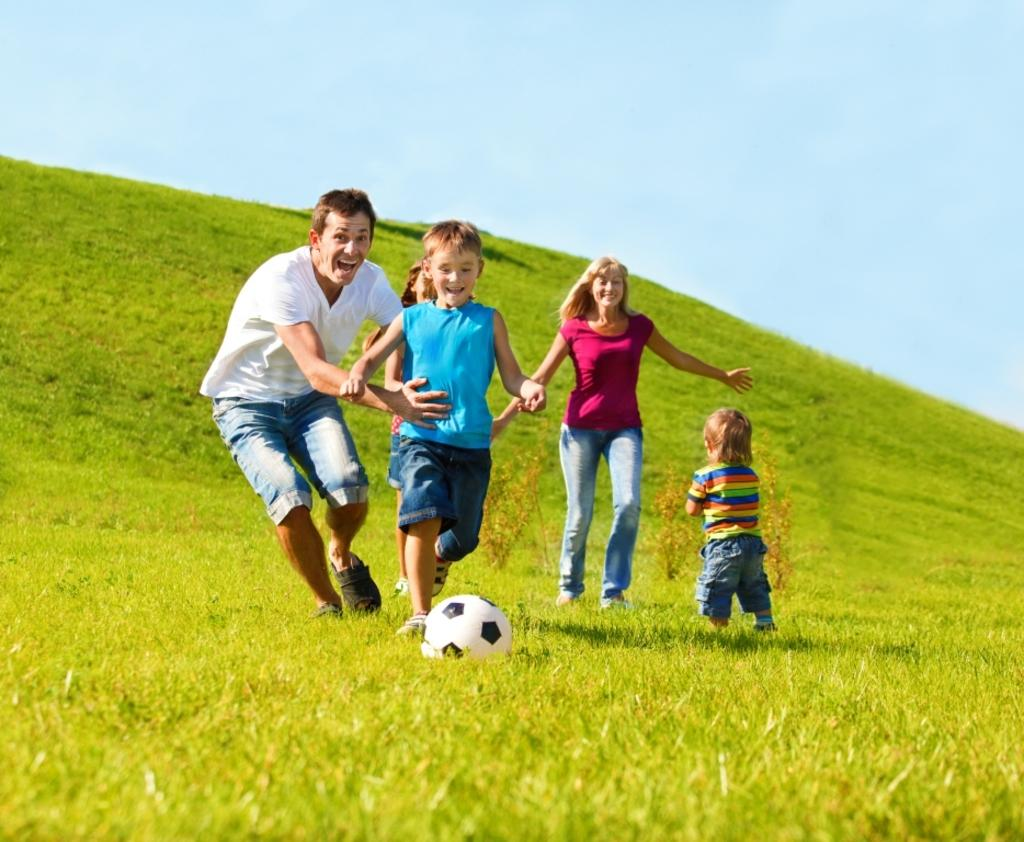What are the people in the image doing? A: The people in the image are running on the grass. What object is in front of the people? There is a ball in front of the people. What can be seen behind the people? There are plants behind the people. What is visible in the background of the image? The sky is visible in the background of the image. What color of paint is being used to decorate the middle of the image? There is no paint or middle section present in the image; it features people running on the grass with a ball and plants in the background. 